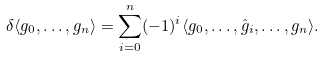Convert formula to latex. <formula><loc_0><loc_0><loc_500><loc_500>\delta \langle g _ { 0 } , \dots , g _ { n } \rangle = \sum _ { i = 0 } ^ { n } ( - 1 ) ^ { i } \langle g _ { 0 } , \dots , \hat { g } _ { i } , \dots , g _ { n } \rangle .</formula> 